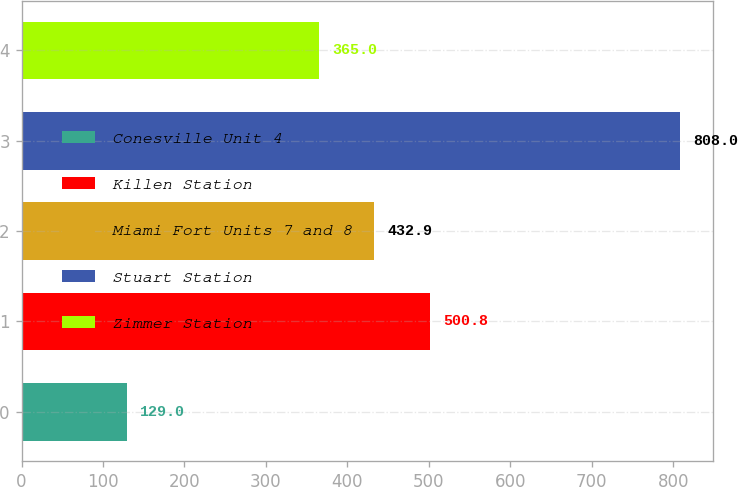Convert chart to OTSL. <chart><loc_0><loc_0><loc_500><loc_500><bar_chart><fcel>Conesville Unit 4<fcel>Killen Station<fcel>Miami Fort Units 7 and 8<fcel>Stuart Station<fcel>Zimmer Station<nl><fcel>129<fcel>500.8<fcel>432.9<fcel>808<fcel>365<nl></chart> 